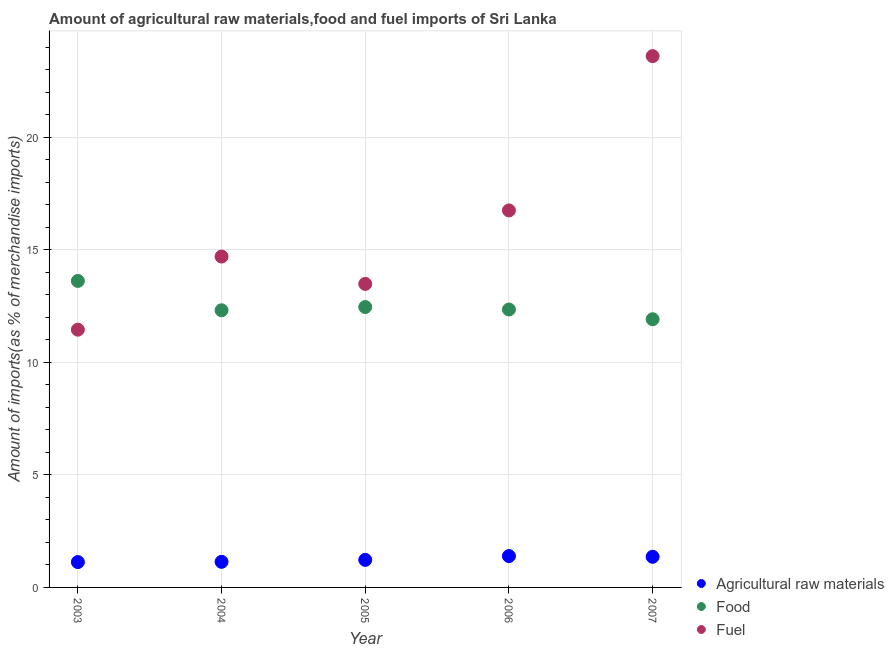Is the number of dotlines equal to the number of legend labels?
Keep it short and to the point. Yes. What is the percentage of food imports in 2003?
Offer a very short reply. 13.62. Across all years, what is the maximum percentage of raw materials imports?
Provide a short and direct response. 1.39. Across all years, what is the minimum percentage of raw materials imports?
Offer a very short reply. 1.13. In which year was the percentage of fuel imports maximum?
Give a very brief answer. 2007. In which year was the percentage of food imports minimum?
Give a very brief answer. 2007. What is the total percentage of fuel imports in the graph?
Your answer should be very brief. 80. What is the difference between the percentage of fuel imports in 2003 and that in 2006?
Ensure brevity in your answer.  -5.3. What is the difference between the percentage of food imports in 2007 and the percentage of raw materials imports in 2004?
Your answer should be compact. 10.78. What is the average percentage of food imports per year?
Ensure brevity in your answer.  12.53. In the year 2006, what is the difference between the percentage of food imports and percentage of raw materials imports?
Your response must be concise. 10.96. In how many years, is the percentage of fuel imports greater than 6 %?
Your answer should be compact. 5. What is the ratio of the percentage of raw materials imports in 2003 to that in 2004?
Keep it short and to the point. 0.99. Is the percentage of raw materials imports in 2004 less than that in 2005?
Your answer should be compact. Yes. Is the difference between the percentage of fuel imports in 2004 and 2007 greater than the difference between the percentage of raw materials imports in 2004 and 2007?
Your answer should be very brief. No. What is the difference between the highest and the second highest percentage of raw materials imports?
Provide a short and direct response. 0.03. What is the difference between the highest and the lowest percentage of food imports?
Offer a very short reply. 1.7. In how many years, is the percentage of fuel imports greater than the average percentage of fuel imports taken over all years?
Your response must be concise. 2. Does the percentage of fuel imports monotonically increase over the years?
Provide a succinct answer. No. Is the percentage of food imports strictly greater than the percentage of fuel imports over the years?
Offer a terse response. No. How many years are there in the graph?
Offer a terse response. 5. How many legend labels are there?
Your response must be concise. 3. What is the title of the graph?
Offer a terse response. Amount of agricultural raw materials,food and fuel imports of Sri Lanka. What is the label or title of the Y-axis?
Give a very brief answer. Amount of imports(as % of merchandise imports). What is the Amount of imports(as % of merchandise imports) in Agricultural raw materials in 2003?
Give a very brief answer. 1.13. What is the Amount of imports(as % of merchandise imports) in Food in 2003?
Provide a succinct answer. 13.62. What is the Amount of imports(as % of merchandise imports) of Fuel in 2003?
Offer a very short reply. 11.45. What is the Amount of imports(as % of merchandise imports) in Agricultural raw materials in 2004?
Keep it short and to the point. 1.14. What is the Amount of imports(as % of merchandise imports) of Food in 2004?
Make the answer very short. 12.32. What is the Amount of imports(as % of merchandise imports) in Fuel in 2004?
Make the answer very short. 14.7. What is the Amount of imports(as % of merchandise imports) of Agricultural raw materials in 2005?
Give a very brief answer. 1.22. What is the Amount of imports(as % of merchandise imports) of Food in 2005?
Provide a succinct answer. 12.46. What is the Amount of imports(as % of merchandise imports) of Fuel in 2005?
Your answer should be compact. 13.49. What is the Amount of imports(as % of merchandise imports) of Agricultural raw materials in 2006?
Your answer should be compact. 1.39. What is the Amount of imports(as % of merchandise imports) in Food in 2006?
Give a very brief answer. 12.35. What is the Amount of imports(as % of merchandise imports) in Fuel in 2006?
Offer a terse response. 16.75. What is the Amount of imports(as % of merchandise imports) of Agricultural raw materials in 2007?
Your response must be concise. 1.36. What is the Amount of imports(as % of merchandise imports) of Food in 2007?
Offer a very short reply. 11.92. What is the Amount of imports(as % of merchandise imports) in Fuel in 2007?
Keep it short and to the point. 23.61. Across all years, what is the maximum Amount of imports(as % of merchandise imports) of Agricultural raw materials?
Offer a terse response. 1.39. Across all years, what is the maximum Amount of imports(as % of merchandise imports) in Food?
Ensure brevity in your answer.  13.62. Across all years, what is the maximum Amount of imports(as % of merchandise imports) of Fuel?
Offer a terse response. 23.61. Across all years, what is the minimum Amount of imports(as % of merchandise imports) in Agricultural raw materials?
Provide a short and direct response. 1.13. Across all years, what is the minimum Amount of imports(as % of merchandise imports) in Food?
Your response must be concise. 11.92. Across all years, what is the minimum Amount of imports(as % of merchandise imports) in Fuel?
Offer a terse response. 11.45. What is the total Amount of imports(as % of merchandise imports) of Agricultural raw materials in the graph?
Provide a succinct answer. 6.24. What is the total Amount of imports(as % of merchandise imports) of Food in the graph?
Give a very brief answer. 62.66. What is the total Amount of imports(as % of merchandise imports) in Fuel in the graph?
Provide a short and direct response. 80. What is the difference between the Amount of imports(as % of merchandise imports) of Agricultural raw materials in 2003 and that in 2004?
Keep it short and to the point. -0.01. What is the difference between the Amount of imports(as % of merchandise imports) in Food in 2003 and that in 2004?
Ensure brevity in your answer.  1.3. What is the difference between the Amount of imports(as % of merchandise imports) in Fuel in 2003 and that in 2004?
Provide a short and direct response. -3.25. What is the difference between the Amount of imports(as % of merchandise imports) in Agricultural raw materials in 2003 and that in 2005?
Keep it short and to the point. -0.1. What is the difference between the Amount of imports(as % of merchandise imports) of Food in 2003 and that in 2005?
Your answer should be very brief. 1.16. What is the difference between the Amount of imports(as % of merchandise imports) in Fuel in 2003 and that in 2005?
Keep it short and to the point. -2.03. What is the difference between the Amount of imports(as % of merchandise imports) of Agricultural raw materials in 2003 and that in 2006?
Ensure brevity in your answer.  -0.27. What is the difference between the Amount of imports(as % of merchandise imports) in Food in 2003 and that in 2006?
Your response must be concise. 1.27. What is the difference between the Amount of imports(as % of merchandise imports) of Fuel in 2003 and that in 2006?
Your response must be concise. -5.3. What is the difference between the Amount of imports(as % of merchandise imports) of Agricultural raw materials in 2003 and that in 2007?
Your response must be concise. -0.24. What is the difference between the Amount of imports(as % of merchandise imports) of Food in 2003 and that in 2007?
Provide a succinct answer. 1.7. What is the difference between the Amount of imports(as % of merchandise imports) of Fuel in 2003 and that in 2007?
Your response must be concise. -12.16. What is the difference between the Amount of imports(as % of merchandise imports) of Agricultural raw materials in 2004 and that in 2005?
Offer a terse response. -0.09. What is the difference between the Amount of imports(as % of merchandise imports) in Food in 2004 and that in 2005?
Your answer should be very brief. -0.14. What is the difference between the Amount of imports(as % of merchandise imports) of Fuel in 2004 and that in 2005?
Keep it short and to the point. 1.22. What is the difference between the Amount of imports(as % of merchandise imports) in Agricultural raw materials in 2004 and that in 2006?
Ensure brevity in your answer.  -0.26. What is the difference between the Amount of imports(as % of merchandise imports) in Food in 2004 and that in 2006?
Ensure brevity in your answer.  -0.03. What is the difference between the Amount of imports(as % of merchandise imports) in Fuel in 2004 and that in 2006?
Your answer should be compact. -2.05. What is the difference between the Amount of imports(as % of merchandise imports) of Agricultural raw materials in 2004 and that in 2007?
Offer a terse response. -0.22. What is the difference between the Amount of imports(as % of merchandise imports) in Food in 2004 and that in 2007?
Your response must be concise. 0.4. What is the difference between the Amount of imports(as % of merchandise imports) in Fuel in 2004 and that in 2007?
Make the answer very short. -8.91. What is the difference between the Amount of imports(as % of merchandise imports) of Agricultural raw materials in 2005 and that in 2006?
Make the answer very short. -0.17. What is the difference between the Amount of imports(as % of merchandise imports) of Food in 2005 and that in 2006?
Keep it short and to the point. 0.11. What is the difference between the Amount of imports(as % of merchandise imports) in Fuel in 2005 and that in 2006?
Your answer should be very brief. -3.27. What is the difference between the Amount of imports(as % of merchandise imports) of Agricultural raw materials in 2005 and that in 2007?
Your response must be concise. -0.14. What is the difference between the Amount of imports(as % of merchandise imports) of Food in 2005 and that in 2007?
Give a very brief answer. 0.54. What is the difference between the Amount of imports(as % of merchandise imports) in Fuel in 2005 and that in 2007?
Offer a terse response. -10.12. What is the difference between the Amount of imports(as % of merchandise imports) of Agricultural raw materials in 2006 and that in 2007?
Make the answer very short. 0.03. What is the difference between the Amount of imports(as % of merchandise imports) of Food in 2006 and that in 2007?
Ensure brevity in your answer.  0.43. What is the difference between the Amount of imports(as % of merchandise imports) of Fuel in 2006 and that in 2007?
Provide a short and direct response. -6.86. What is the difference between the Amount of imports(as % of merchandise imports) of Agricultural raw materials in 2003 and the Amount of imports(as % of merchandise imports) of Food in 2004?
Provide a short and direct response. -11.19. What is the difference between the Amount of imports(as % of merchandise imports) of Agricultural raw materials in 2003 and the Amount of imports(as % of merchandise imports) of Fuel in 2004?
Offer a very short reply. -13.58. What is the difference between the Amount of imports(as % of merchandise imports) of Food in 2003 and the Amount of imports(as % of merchandise imports) of Fuel in 2004?
Give a very brief answer. -1.08. What is the difference between the Amount of imports(as % of merchandise imports) in Agricultural raw materials in 2003 and the Amount of imports(as % of merchandise imports) in Food in 2005?
Your response must be concise. -11.33. What is the difference between the Amount of imports(as % of merchandise imports) in Agricultural raw materials in 2003 and the Amount of imports(as % of merchandise imports) in Fuel in 2005?
Your answer should be compact. -12.36. What is the difference between the Amount of imports(as % of merchandise imports) in Food in 2003 and the Amount of imports(as % of merchandise imports) in Fuel in 2005?
Provide a short and direct response. 0.13. What is the difference between the Amount of imports(as % of merchandise imports) in Agricultural raw materials in 2003 and the Amount of imports(as % of merchandise imports) in Food in 2006?
Offer a very short reply. -11.22. What is the difference between the Amount of imports(as % of merchandise imports) of Agricultural raw materials in 2003 and the Amount of imports(as % of merchandise imports) of Fuel in 2006?
Offer a very short reply. -15.63. What is the difference between the Amount of imports(as % of merchandise imports) of Food in 2003 and the Amount of imports(as % of merchandise imports) of Fuel in 2006?
Provide a succinct answer. -3.13. What is the difference between the Amount of imports(as % of merchandise imports) of Agricultural raw materials in 2003 and the Amount of imports(as % of merchandise imports) of Food in 2007?
Make the answer very short. -10.79. What is the difference between the Amount of imports(as % of merchandise imports) of Agricultural raw materials in 2003 and the Amount of imports(as % of merchandise imports) of Fuel in 2007?
Offer a very short reply. -22.48. What is the difference between the Amount of imports(as % of merchandise imports) of Food in 2003 and the Amount of imports(as % of merchandise imports) of Fuel in 2007?
Ensure brevity in your answer.  -9.99. What is the difference between the Amount of imports(as % of merchandise imports) in Agricultural raw materials in 2004 and the Amount of imports(as % of merchandise imports) in Food in 2005?
Your response must be concise. -11.32. What is the difference between the Amount of imports(as % of merchandise imports) in Agricultural raw materials in 2004 and the Amount of imports(as % of merchandise imports) in Fuel in 2005?
Give a very brief answer. -12.35. What is the difference between the Amount of imports(as % of merchandise imports) in Food in 2004 and the Amount of imports(as % of merchandise imports) in Fuel in 2005?
Your answer should be compact. -1.17. What is the difference between the Amount of imports(as % of merchandise imports) in Agricultural raw materials in 2004 and the Amount of imports(as % of merchandise imports) in Food in 2006?
Your answer should be very brief. -11.21. What is the difference between the Amount of imports(as % of merchandise imports) in Agricultural raw materials in 2004 and the Amount of imports(as % of merchandise imports) in Fuel in 2006?
Keep it short and to the point. -15.62. What is the difference between the Amount of imports(as % of merchandise imports) of Food in 2004 and the Amount of imports(as % of merchandise imports) of Fuel in 2006?
Offer a very short reply. -4.44. What is the difference between the Amount of imports(as % of merchandise imports) of Agricultural raw materials in 2004 and the Amount of imports(as % of merchandise imports) of Food in 2007?
Keep it short and to the point. -10.78. What is the difference between the Amount of imports(as % of merchandise imports) of Agricultural raw materials in 2004 and the Amount of imports(as % of merchandise imports) of Fuel in 2007?
Your answer should be very brief. -22.47. What is the difference between the Amount of imports(as % of merchandise imports) of Food in 2004 and the Amount of imports(as % of merchandise imports) of Fuel in 2007?
Offer a terse response. -11.29. What is the difference between the Amount of imports(as % of merchandise imports) in Agricultural raw materials in 2005 and the Amount of imports(as % of merchandise imports) in Food in 2006?
Offer a very short reply. -11.13. What is the difference between the Amount of imports(as % of merchandise imports) in Agricultural raw materials in 2005 and the Amount of imports(as % of merchandise imports) in Fuel in 2006?
Keep it short and to the point. -15.53. What is the difference between the Amount of imports(as % of merchandise imports) in Food in 2005 and the Amount of imports(as % of merchandise imports) in Fuel in 2006?
Provide a succinct answer. -4.29. What is the difference between the Amount of imports(as % of merchandise imports) in Agricultural raw materials in 2005 and the Amount of imports(as % of merchandise imports) in Food in 2007?
Provide a succinct answer. -10.69. What is the difference between the Amount of imports(as % of merchandise imports) of Agricultural raw materials in 2005 and the Amount of imports(as % of merchandise imports) of Fuel in 2007?
Provide a succinct answer. -22.38. What is the difference between the Amount of imports(as % of merchandise imports) in Food in 2005 and the Amount of imports(as % of merchandise imports) in Fuel in 2007?
Ensure brevity in your answer.  -11.15. What is the difference between the Amount of imports(as % of merchandise imports) of Agricultural raw materials in 2006 and the Amount of imports(as % of merchandise imports) of Food in 2007?
Offer a terse response. -10.52. What is the difference between the Amount of imports(as % of merchandise imports) in Agricultural raw materials in 2006 and the Amount of imports(as % of merchandise imports) in Fuel in 2007?
Your answer should be very brief. -22.22. What is the difference between the Amount of imports(as % of merchandise imports) in Food in 2006 and the Amount of imports(as % of merchandise imports) in Fuel in 2007?
Provide a succinct answer. -11.26. What is the average Amount of imports(as % of merchandise imports) in Agricultural raw materials per year?
Offer a very short reply. 1.25. What is the average Amount of imports(as % of merchandise imports) in Food per year?
Your answer should be compact. 12.53. What is the average Amount of imports(as % of merchandise imports) of Fuel per year?
Your answer should be compact. 16. In the year 2003, what is the difference between the Amount of imports(as % of merchandise imports) of Agricultural raw materials and Amount of imports(as % of merchandise imports) of Food?
Your answer should be compact. -12.49. In the year 2003, what is the difference between the Amount of imports(as % of merchandise imports) of Agricultural raw materials and Amount of imports(as % of merchandise imports) of Fuel?
Provide a short and direct response. -10.33. In the year 2003, what is the difference between the Amount of imports(as % of merchandise imports) of Food and Amount of imports(as % of merchandise imports) of Fuel?
Offer a terse response. 2.17. In the year 2004, what is the difference between the Amount of imports(as % of merchandise imports) of Agricultural raw materials and Amount of imports(as % of merchandise imports) of Food?
Give a very brief answer. -11.18. In the year 2004, what is the difference between the Amount of imports(as % of merchandise imports) in Agricultural raw materials and Amount of imports(as % of merchandise imports) in Fuel?
Provide a short and direct response. -13.56. In the year 2004, what is the difference between the Amount of imports(as % of merchandise imports) of Food and Amount of imports(as % of merchandise imports) of Fuel?
Make the answer very short. -2.39. In the year 2005, what is the difference between the Amount of imports(as % of merchandise imports) in Agricultural raw materials and Amount of imports(as % of merchandise imports) in Food?
Ensure brevity in your answer.  -11.24. In the year 2005, what is the difference between the Amount of imports(as % of merchandise imports) of Agricultural raw materials and Amount of imports(as % of merchandise imports) of Fuel?
Provide a short and direct response. -12.26. In the year 2005, what is the difference between the Amount of imports(as % of merchandise imports) of Food and Amount of imports(as % of merchandise imports) of Fuel?
Your response must be concise. -1.03. In the year 2006, what is the difference between the Amount of imports(as % of merchandise imports) in Agricultural raw materials and Amount of imports(as % of merchandise imports) in Food?
Make the answer very short. -10.96. In the year 2006, what is the difference between the Amount of imports(as % of merchandise imports) in Agricultural raw materials and Amount of imports(as % of merchandise imports) in Fuel?
Your answer should be very brief. -15.36. In the year 2006, what is the difference between the Amount of imports(as % of merchandise imports) of Food and Amount of imports(as % of merchandise imports) of Fuel?
Your answer should be very brief. -4.4. In the year 2007, what is the difference between the Amount of imports(as % of merchandise imports) in Agricultural raw materials and Amount of imports(as % of merchandise imports) in Food?
Provide a short and direct response. -10.56. In the year 2007, what is the difference between the Amount of imports(as % of merchandise imports) in Agricultural raw materials and Amount of imports(as % of merchandise imports) in Fuel?
Your response must be concise. -22.25. In the year 2007, what is the difference between the Amount of imports(as % of merchandise imports) of Food and Amount of imports(as % of merchandise imports) of Fuel?
Ensure brevity in your answer.  -11.69. What is the ratio of the Amount of imports(as % of merchandise imports) of Agricultural raw materials in 2003 to that in 2004?
Ensure brevity in your answer.  0.99. What is the ratio of the Amount of imports(as % of merchandise imports) of Food in 2003 to that in 2004?
Keep it short and to the point. 1.11. What is the ratio of the Amount of imports(as % of merchandise imports) in Fuel in 2003 to that in 2004?
Offer a terse response. 0.78. What is the ratio of the Amount of imports(as % of merchandise imports) of Agricultural raw materials in 2003 to that in 2005?
Provide a succinct answer. 0.92. What is the ratio of the Amount of imports(as % of merchandise imports) of Food in 2003 to that in 2005?
Offer a very short reply. 1.09. What is the ratio of the Amount of imports(as % of merchandise imports) of Fuel in 2003 to that in 2005?
Your answer should be compact. 0.85. What is the ratio of the Amount of imports(as % of merchandise imports) of Agricultural raw materials in 2003 to that in 2006?
Provide a short and direct response. 0.81. What is the ratio of the Amount of imports(as % of merchandise imports) of Food in 2003 to that in 2006?
Give a very brief answer. 1.1. What is the ratio of the Amount of imports(as % of merchandise imports) in Fuel in 2003 to that in 2006?
Offer a very short reply. 0.68. What is the ratio of the Amount of imports(as % of merchandise imports) in Agricultural raw materials in 2003 to that in 2007?
Make the answer very short. 0.83. What is the ratio of the Amount of imports(as % of merchandise imports) of Food in 2003 to that in 2007?
Give a very brief answer. 1.14. What is the ratio of the Amount of imports(as % of merchandise imports) in Fuel in 2003 to that in 2007?
Offer a very short reply. 0.49. What is the ratio of the Amount of imports(as % of merchandise imports) in Agricultural raw materials in 2004 to that in 2005?
Your answer should be compact. 0.93. What is the ratio of the Amount of imports(as % of merchandise imports) of Food in 2004 to that in 2005?
Offer a terse response. 0.99. What is the ratio of the Amount of imports(as % of merchandise imports) in Fuel in 2004 to that in 2005?
Offer a terse response. 1.09. What is the ratio of the Amount of imports(as % of merchandise imports) in Agricultural raw materials in 2004 to that in 2006?
Your answer should be compact. 0.82. What is the ratio of the Amount of imports(as % of merchandise imports) of Fuel in 2004 to that in 2006?
Offer a very short reply. 0.88. What is the ratio of the Amount of imports(as % of merchandise imports) in Agricultural raw materials in 2004 to that in 2007?
Offer a terse response. 0.84. What is the ratio of the Amount of imports(as % of merchandise imports) in Food in 2004 to that in 2007?
Your answer should be very brief. 1.03. What is the ratio of the Amount of imports(as % of merchandise imports) in Fuel in 2004 to that in 2007?
Provide a short and direct response. 0.62. What is the ratio of the Amount of imports(as % of merchandise imports) of Agricultural raw materials in 2005 to that in 2006?
Keep it short and to the point. 0.88. What is the ratio of the Amount of imports(as % of merchandise imports) in Food in 2005 to that in 2006?
Offer a very short reply. 1.01. What is the ratio of the Amount of imports(as % of merchandise imports) of Fuel in 2005 to that in 2006?
Give a very brief answer. 0.81. What is the ratio of the Amount of imports(as % of merchandise imports) of Agricultural raw materials in 2005 to that in 2007?
Offer a terse response. 0.9. What is the ratio of the Amount of imports(as % of merchandise imports) of Food in 2005 to that in 2007?
Your answer should be very brief. 1.05. What is the ratio of the Amount of imports(as % of merchandise imports) of Fuel in 2005 to that in 2007?
Give a very brief answer. 0.57. What is the ratio of the Amount of imports(as % of merchandise imports) of Agricultural raw materials in 2006 to that in 2007?
Your response must be concise. 1.02. What is the ratio of the Amount of imports(as % of merchandise imports) of Food in 2006 to that in 2007?
Offer a very short reply. 1.04. What is the ratio of the Amount of imports(as % of merchandise imports) in Fuel in 2006 to that in 2007?
Provide a succinct answer. 0.71. What is the difference between the highest and the second highest Amount of imports(as % of merchandise imports) in Agricultural raw materials?
Ensure brevity in your answer.  0.03. What is the difference between the highest and the second highest Amount of imports(as % of merchandise imports) of Food?
Give a very brief answer. 1.16. What is the difference between the highest and the second highest Amount of imports(as % of merchandise imports) in Fuel?
Provide a succinct answer. 6.86. What is the difference between the highest and the lowest Amount of imports(as % of merchandise imports) of Agricultural raw materials?
Ensure brevity in your answer.  0.27. What is the difference between the highest and the lowest Amount of imports(as % of merchandise imports) of Food?
Keep it short and to the point. 1.7. What is the difference between the highest and the lowest Amount of imports(as % of merchandise imports) in Fuel?
Offer a terse response. 12.16. 